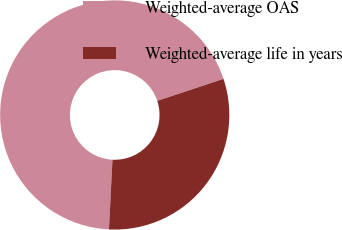<chart> <loc_0><loc_0><loc_500><loc_500><pie_chart><fcel>Weighted-average OAS<fcel>Weighted-average life in years<nl><fcel>69.1%<fcel>30.9%<nl></chart> 